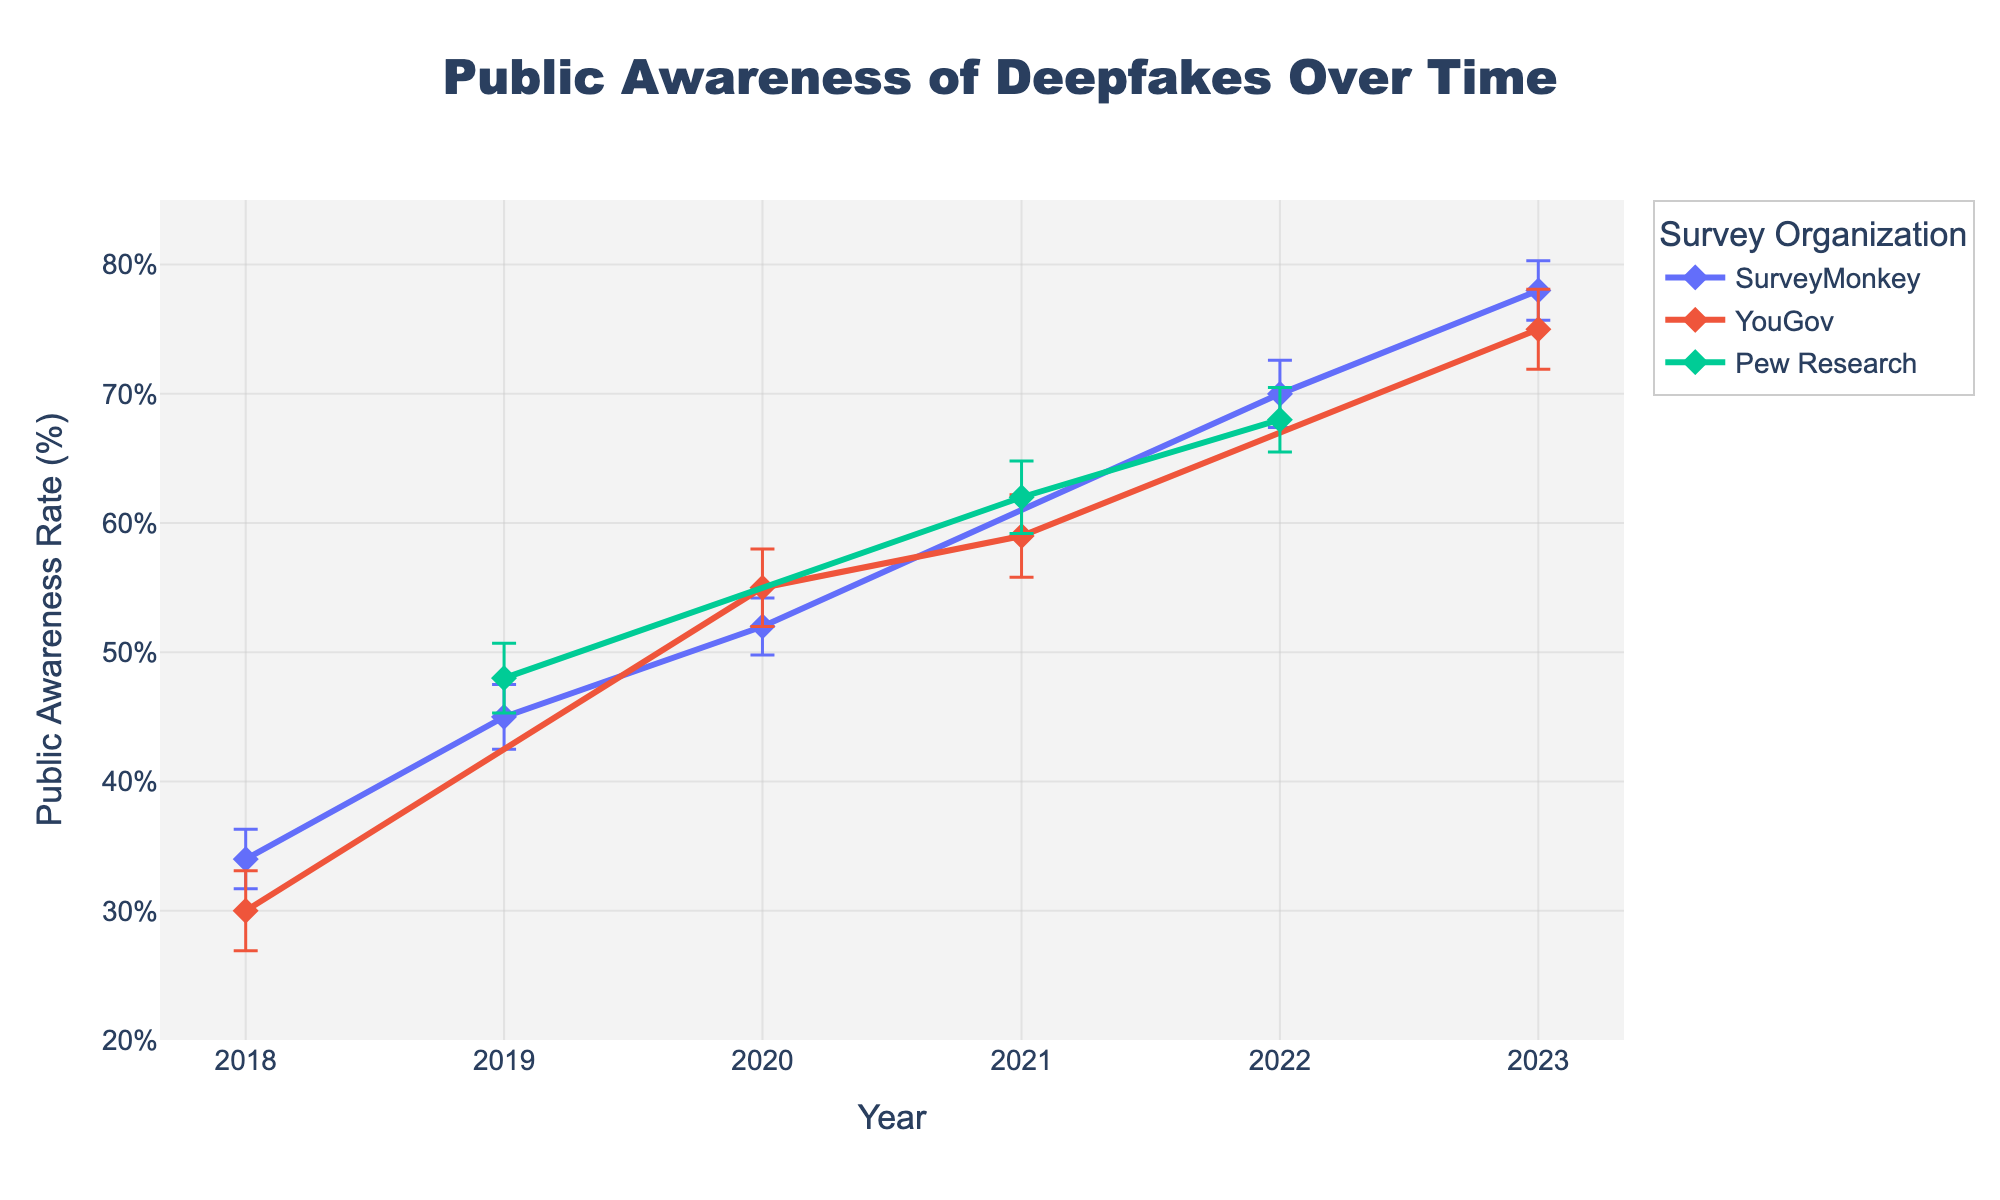What is the title of the plot? The title is located at the top of the plot and it reads "Public Awareness of Deepfakes Over Time".
Answer: Public Awareness of Deepfakes Over Time Which survey organization reported the highest public awareness rate in 2023? The data points for 2023 should be identified, and the highest value among them is determined. SurveyMonkey reported 78%, which is higher compared to YouGov’s 75%.
Answer: SurveyMonkey In which year did Pew Research conduct surveys, and what were the public awareness rates they reported? Locate the data points labeled Pew Research and note the corresponding years and values. Pew Research conducted surveys in 2019, 2021, and 2022, with awareness rates of 48%, 62%, and 68% respectively.
Answer: 2019 (48%), 2021 (62%), 2022 (68%) What was the range of public awareness rates reported by SurveyMonkey over the years? Identify the minimum and maximum public awareness rates reported by SurveyMonkey in the respective years and subtract the minimum from the maximum. SurveyMonkey reported rates from 34% to 78%. The range is 78% - 34% = 44%.
Answer: 44% Considering the margin of error, in which year did YouGov report the lowest public awareness rate and what was it? Look for data points labeled YouGov and consider the margin of error to identify the lowest rate. YouGov reported the lowest rate in 2018, which is 30% ± 3.1.
Answer: 2018 (30%) Between 2018 and 2023, by how many percentage points did SurveyMonkey’s public awareness rate change? Note SurveyMonkey’s rates in 2018 and 2023 and calculate the difference. The change is 78% (2023) - 34% (2018) = 44 percentage points.
Answer: 44 percentage points Did any survey organization report a public awareness rate of over 70% before 2022? Check all data points before 2022 to see if any reported rate exceeds 70%. No organization reported over 70% before 2022.
Answer: No Which year had the greatest combined public awareness rate from all survey organizations, and what was the sum? Sum the rates reported by all organizations for each year and identify the highest sum. The greatest combined rate is in 2022 with a sum of 70 (SurveyMonkey) + 68 (Pew Research) = 138%.
Answer: 2022 (138%) What is the average public awareness rate reported by YouGov over the years? Add all rates reported by YouGov and divide by the number of years they conducted surveys: (30 + 55 + 59 + 75) / 4 = 54.75%.
Answer: 54.75% By how much did the public awareness rate reported by Pew Research change between 2019 and 2021? Find the difference between Pew Research's rates in these years. The change is 62% (2021) - 48% (2019) = 14 percentage points.
Answer: 14 percentage points 